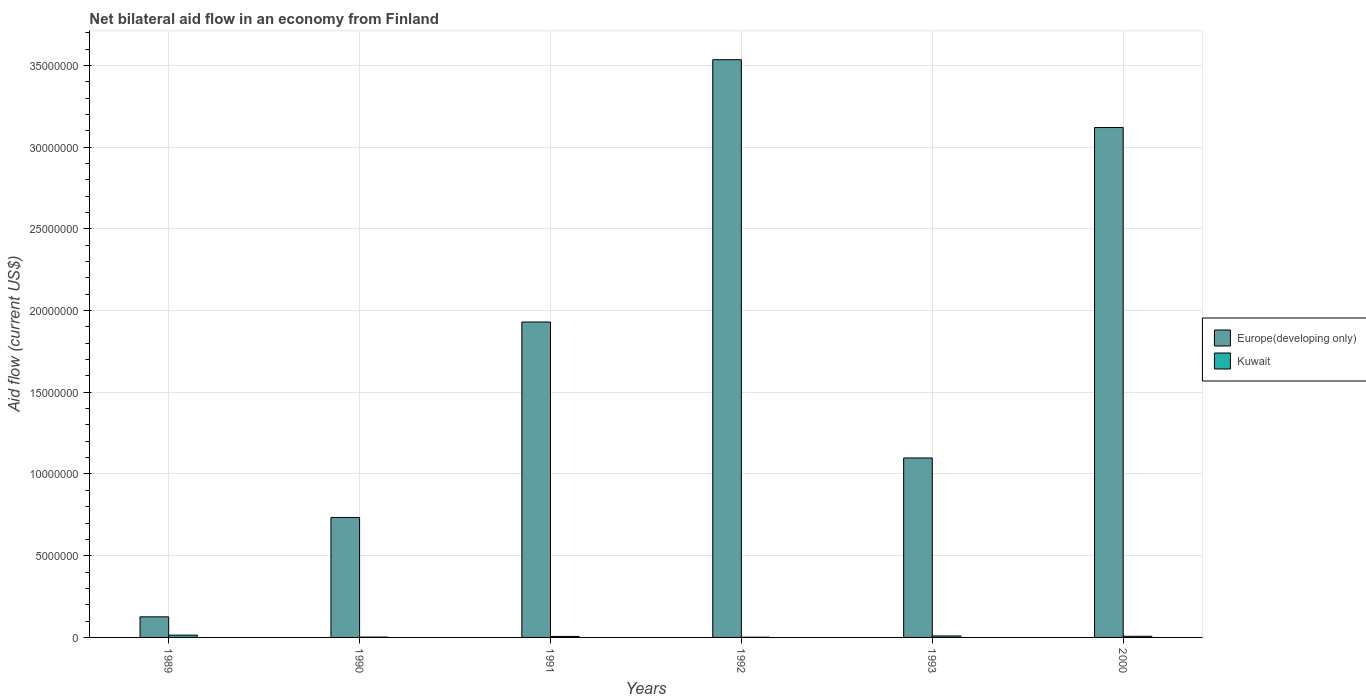How many groups of bars are there?
Provide a succinct answer. 6. Are the number of bars per tick equal to the number of legend labels?
Make the answer very short. Yes. Are the number of bars on each tick of the X-axis equal?
Provide a succinct answer. Yes. How many bars are there on the 3rd tick from the left?
Your answer should be very brief. 2. How many bars are there on the 2nd tick from the right?
Offer a terse response. 2. What is the label of the 5th group of bars from the left?
Offer a terse response. 1993. In how many cases, is the number of bars for a given year not equal to the number of legend labels?
Your response must be concise. 0. Across all years, what is the maximum net bilateral aid flow in Europe(developing only)?
Make the answer very short. 3.54e+07. Across all years, what is the minimum net bilateral aid flow in Europe(developing only)?
Give a very brief answer. 1.26e+06. In which year was the net bilateral aid flow in Kuwait maximum?
Your answer should be very brief. 1989. What is the total net bilateral aid flow in Kuwait in the graph?
Your answer should be very brief. 3.90e+05. What is the difference between the net bilateral aid flow in Europe(developing only) in 1990 and that in 1993?
Offer a very short reply. -3.64e+06. What is the difference between the net bilateral aid flow in Europe(developing only) in 1991 and the net bilateral aid flow in Kuwait in 1990?
Make the answer very short. 1.93e+07. What is the average net bilateral aid flow in Europe(developing only) per year?
Ensure brevity in your answer.  1.76e+07. In the year 1991, what is the difference between the net bilateral aid flow in Kuwait and net bilateral aid flow in Europe(developing only)?
Provide a succinct answer. -1.92e+07. In how many years, is the net bilateral aid flow in Europe(developing only) greater than 23000000 US$?
Offer a very short reply. 2. What is the ratio of the net bilateral aid flow in Europe(developing only) in 1992 to that in 1993?
Make the answer very short. 3.22. Is the net bilateral aid flow in Europe(developing only) in 1991 less than that in 1992?
Make the answer very short. Yes. Is the difference between the net bilateral aid flow in Kuwait in 1989 and 1991 greater than the difference between the net bilateral aid flow in Europe(developing only) in 1989 and 1991?
Your response must be concise. Yes. What is the difference between the highest and the lowest net bilateral aid flow in Europe(developing only)?
Make the answer very short. 3.41e+07. In how many years, is the net bilateral aid flow in Kuwait greater than the average net bilateral aid flow in Kuwait taken over all years?
Provide a succinct answer. 3. What does the 2nd bar from the left in 1990 represents?
Your answer should be compact. Kuwait. What does the 1st bar from the right in 2000 represents?
Offer a very short reply. Kuwait. Are all the bars in the graph horizontal?
Offer a terse response. No. How many years are there in the graph?
Ensure brevity in your answer.  6. What is the difference between two consecutive major ticks on the Y-axis?
Offer a terse response. 5.00e+06. Does the graph contain any zero values?
Offer a very short reply. No. Does the graph contain grids?
Offer a very short reply. Yes. Where does the legend appear in the graph?
Provide a short and direct response. Center right. How are the legend labels stacked?
Provide a short and direct response. Vertical. What is the title of the graph?
Your answer should be very brief. Net bilateral aid flow in an economy from Finland. What is the Aid flow (current US$) of Europe(developing only) in 1989?
Your answer should be very brief. 1.26e+06. What is the Aid flow (current US$) of Europe(developing only) in 1990?
Your answer should be compact. 7.34e+06. What is the Aid flow (current US$) of Kuwait in 1990?
Your answer should be very brief. 2.00e+04. What is the Aid flow (current US$) of Europe(developing only) in 1991?
Your answer should be compact. 1.93e+07. What is the Aid flow (current US$) of Kuwait in 1991?
Offer a very short reply. 6.00e+04. What is the Aid flow (current US$) in Europe(developing only) in 1992?
Keep it short and to the point. 3.54e+07. What is the Aid flow (current US$) of Kuwait in 1992?
Provide a short and direct response. 10000. What is the Aid flow (current US$) of Europe(developing only) in 1993?
Provide a short and direct response. 1.10e+07. What is the Aid flow (current US$) in Europe(developing only) in 2000?
Offer a terse response. 3.12e+07. What is the Aid flow (current US$) of Kuwait in 2000?
Offer a terse response. 7.00e+04. Across all years, what is the maximum Aid flow (current US$) of Europe(developing only)?
Your answer should be compact. 3.54e+07. Across all years, what is the maximum Aid flow (current US$) of Kuwait?
Offer a terse response. 1.40e+05. Across all years, what is the minimum Aid flow (current US$) in Europe(developing only)?
Offer a terse response. 1.26e+06. Across all years, what is the minimum Aid flow (current US$) in Kuwait?
Your answer should be very brief. 10000. What is the total Aid flow (current US$) of Europe(developing only) in the graph?
Offer a very short reply. 1.05e+08. What is the total Aid flow (current US$) in Kuwait in the graph?
Your response must be concise. 3.90e+05. What is the difference between the Aid flow (current US$) in Europe(developing only) in 1989 and that in 1990?
Offer a very short reply. -6.08e+06. What is the difference between the Aid flow (current US$) of Kuwait in 1989 and that in 1990?
Provide a succinct answer. 1.20e+05. What is the difference between the Aid flow (current US$) of Europe(developing only) in 1989 and that in 1991?
Give a very brief answer. -1.80e+07. What is the difference between the Aid flow (current US$) of Kuwait in 1989 and that in 1991?
Offer a terse response. 8.00e+04. What is the difference between the Aid flow (current US$) in Europe(developing only) in 1989 and that in 1992?
Your answer should be compact. -3.41e+07. What is the difference between the Aid flow (current US$) in Europe(developing only) in 1989 and that in 1993?
Offer a very short reply. -9.72e+06. What is the difference between the Aid flow (current US$) in Kuwait in 1989 and that in 1993?
Offer a terse response. 5.00e+04. What is the difference between the Aid flow (current US$) in Europe(developing only) in 1989 and that in 2000?
Provide a succinct answer. -2.99e+07. What is the difference between the Aid flow (current US$) in Europe(developing only) in 1990 and that in 1991?
Offer a very short reply. -1.20e+07. What is the difference between the Aid flow (current US$) of Kuwait in 1990 and that in 1991?
Your answer should be very brief. -4.00e+04. What is the difference between the Aid flow (current US$) of Europe(developing only) in 1990 and that in 1992?
Give a very brief answer. -2.80e+07. What is the difference between the Aid flow (current US$) of Kuwait in 1990 and that in 1992?
Offer a very short reply. 10000. What is the difference between the Aid flow (current US$) of Europe(developing only) in 1990 and that in 1993?
Make the answer very short. -3.64e+06. What is the difference between the Aid flow (current US$) of Kuwait in 1990 and that in 1993?
Offer a very short reply. -7.00e+04. What is the difference between the Aid flow (current US$) in Europe(developing only) in 1990 and that in 2000?
Your answer should be very brief. -2.39e+07. What is the difference between the Aid flow (current US$) in Kuwait in 1990 and that in 2000?
Ensure brevity in your answer.  -5.00e+04. What is the difference between the Aid flow (current US$) of Europe(developing only) in 1991 and that in 1992?
Keep it short and to the point. -1.60e+07. What is the difference between the Aid flow (current US$) of Kuwait in 1991 and that in 1992?
Ensure brevity in your answer.  5.00e+04. What is the difference between the Aid flow (current US$) in Europe(developing only) in 1991 and that in 1993?
Offer a terse response. 8.32e+06. What is the difference between the Aid flow (current US$) of Kuwait in 1991 and that in 1993?
Provide a succinct answer. -3.00e+04. What is the difference between the Aid flow (current US$) in Europe(developing only) in 1991 and that in 2000?
Provide a succinct answer. -1.19e+07. What is the difference between the Aid flow (current US$) of Europe(developing only) in 1992 and that in 1993?
Give a very brief answer. 2.44e+07. What is the difference between the Aid flow (current US$) in Europe(developing only) in 1992 and that in 2000?
Make the answer very short. 4.15e+06. What is the difference between the Aid flow (current US$) in Kuwait in 1992 and that in 2000?
Your answer should be compact. -6.00e+04. What is the difference between the Aid flow (current US$) in Europe(developing only) in 1993 and that in 2000?
Your response must be concise. -2.02e+07. What is the difference between the Aid flow (current US$) in Europe(developing only) in 1989 and the Aid flow (current US$) in Kuwait in 1990?
Offer a terse response. 1.24e+06. What is the difference between the Aid flow (current US$) in Europe(developing only) in 1989 and the Aid flow (current US$) in Kuwait in 1991?
Your answer should be very brief. 1.20e+06. What is the difference between the Aid flow (current US$) in Europe(developing only) in 1989 and the Aid flow (current US$) in Kuwait in 1992?
Your answer should be very brief. 1.25e+06. What is the difference between the Aid flow (current US$) of Europe(developing only) in 1989 and the Aid flow (current US$) of Kuwait in 1993?
Your answer should be compact. 1.17e+06. What is the difference between the Aid flow (current US$) of Europe(developing only) in 1989 and the Aid flow (current US$) of Kuwait in 2000?
Offer a terse response. 1.19e+06. What is the difference between the Aid flow (current US$) of Europe(developing only) in 1990 and the Aid flow (current US$) of Kuwait in 1991?
Your answer should be very brief. 7.28e+06. What is the difference between the Aid flow (current US$) in Europe(developing only) in 1990 and the Aid flow (current US$) in Kuwait in 1992?
Make the answer very short. 7.33e+06. What is the difference between the Aid flow (current US$) of Europe(developing only) in 1990 and the Aid flow (current US$) of Kuwait in 1993?
Your answer should be compact. 7.25e+06. What is the difference between the Aid flow (current US$) in Europe(developing only) in 1990 and the Aid flow (current US$) in Kuwait in 2000?
Provide a succinct answer. 7.27e+06. What is the difference between the Aid flow (current US$) in Europe(developing only) in 1991 and the Aid flow (current US$) in Kuwait in 1992?
Offer a terse response. 1.93e+07. What is the difference between the Aid flow (current US$) of Europe(developing only) in 1991 and the Aid flow (current US$) of Kuwait in 1993?
Your answer should be very brief. 1.92e+07. What is the difference between the Aid flow (current US$) of Europe(developing only) in 1991 and the Aid flow (current US$) of Kuwait in 2000?
Your answer should be very brief. 1.92e+07. What is the difference between the Aid flow (current US$) of Europe(developing only) in 1992 and the Aid flow (current US$) of Kuwait in 1993?
Your response must be concise. 3.53e+07. What is the difference between the Aid flow (current US$) in Europe(developing only) in 1992 and the Aid flow (current US$) in Kuwait in 2000?
Ensure brevity in your answer.  3.53e+07. What is the difference between the Aid flow (current US$) of Europe(developing only) in 1993 and the Aid flow (current US$) of Kuwait in 2000?
Make the answer very short. 1.09e+07. What is the average Aid flow (current US$) of Europe(developing only) per year?
Offer a terse response. 1.76e+07. What is the average Aid flow (current US$) in Kuwait per year?
Give a very brief answer. 6.50e+04. In the year 1989, what is the difference between the Aid flow (current US$) of Europe(developing only) and Aid flow (current US$) of Kuwait?
Your response must be concise. 1.12e+06. In the year 1990, what is the difference between the Aid flow (current US$) in Europe(developing only) and Aid flow (current US$) in Kuwait?
Offer a very short reply. 7.32e+06. In the year 1991, what is the difference between the Aid flow (current US$) of Europe(developing only) and Aid flow (current US$) of Kuwait?
Offer a terse response. 1.92e+07. In the year 1992, what is the difference between the Aid flow (current US$) in Europe(developing only) and Aid flow (current US$) in Kuwait?
Give a very brief answer. 3.53e+07. In the year 1993, what is the difference between the Aid flow (current US$) of Europe(developing only) and Aid flow (current US$) of Kuwait?
Give a very brief answer. 1.09e+07. In the year 2000, what is the difference between the Aid flow (current US$) in Europe(developing only) and Aid flow (current US$) in Kuwait?
Keep it short and to the point. 3.11e+07. What is the ratio of the Aid flow (current US$) of Europe(developing only) in 1989 to that in 1990?
Give a very brief answer. 0.17. What is the ratio of the Aid flow (current US$) in Kuwait in 1989 to that in 1990?
Give a very brief answer. 7. What is the ratio of the Aid flow (current US$) in Europe(developing only) in 1989 to that in 1991?
Your answer should be compact. 0.07. What is the ratio of the Aid flow (current US$) in Kuwait in 1989 to that in 1991?
Your answer should be compact. 2.33. What is the ratio of the Aid flow (current US$) of Europe(developing only) in 1989 to that in 1992?
Offer a very short reply. 0.04. What is the ratio of the Aid flow (current US$) of Europe(developing only) in 1989 to that in 1993?
Offer a very short reply. 0.11. What is the ratio of the Aid flow (current US$) of Kuwait in 1989 to that in 1993?
Offer a terse response. 1.56. What is the ratio of the Aid flow (current US$) in Europe(developing only) in 1989 to that in 2000?
Offer a very short reply. 0.04. What is the ratio of the Aid flow (current US$) in Europe(developing only) in 1990 to that in 1991?
Make the answer very short. 0.38. What is the ratio of the Aid flow (current US$) in Kuwait in 1990 to that in 1991?
Your answer should be compact. 0.33. What is the ratio of the Aid flow (current US$) of Europe(developing only) in 1990 to that in 1992?
Provide a succinct answer. 0.21. What is the ratio of the Aid flow (current US$) of Europe(developing only) in 1990 to that in 1993?
Ensure brevity in your answer.  0.67. What is the ratio of the Aid flow (current US$) in Kuwait in 1990 to that in 1993?
Your answer should be compact. 0.22. What is the ratio of the Aid flow (current US$) of Europe(developing only) in 1990 to that in 2000?
Ensure brevity in your answer.  0.24. What is the ratio of the Aid flow (current US$) in Kuwait in 1990 to that in 2000?
Offer a very short reply. 0.29. What is the ratio of the Aid flow (current US$) of Europe(developing only) in 1991 to that in 1992?
Your answer should be very brief. 0.55. What is the ratio of the Aid flow (current US$) in Kuwait in 1991 to that in 1992?
Ensure brevity in your answer.  6. What is the ratio of the Aid flow (current US$) in Europe(developing only) in 1991 to that in 1993?
Make the answer very short. 1.76. What is the ratio of the Aid flow (current US$) of Kuwait in 1991 to that in 1993?
Offer a very short reply. 0.67. What is the ratio of the Aid flow (current US$) in Europe(developing only) in 1991 to that in 2000?
Offer a very short reply. 0.62. What is the ratio of the Aid flow (current US$) in Kuwait in 1991 to that in 2000?
Offer a very short reply. 0.86. What is the ratio of the Aid flow (current US$) of Europe(developing only) in 1992 to that in 1993?
Keep it short and to the point. 3.22. What is the ratio of the Aid flow (current US$) of Kuwait in 1992 to that in 1993?
Provide a succinct answer. 0.11. What is the ratio of the Aid flow (current US$) in Europe(developing only) in 1992 to that in 2000?
Offer a very short reply. 1.13. What is the ratio of the Aid flow (current US$) of Kuwait in 1992 to that in 2000?
Your answer should be very brief. 0.14. What is the ratio of the Aid flow (current US$) of Europe(developing only) in 1993 to that in 2000?
Keep it short and to the point. 0.35. What is the difference between the highest and the second highest Aid flow (current US$) in Europe(developing only)?
Offer a terse response. 4.15e+06. What is the difference between the highest and the lowest Aid flow (current US$) in Europe(developing only)?
Offer a terse response. 3.41e+07. 